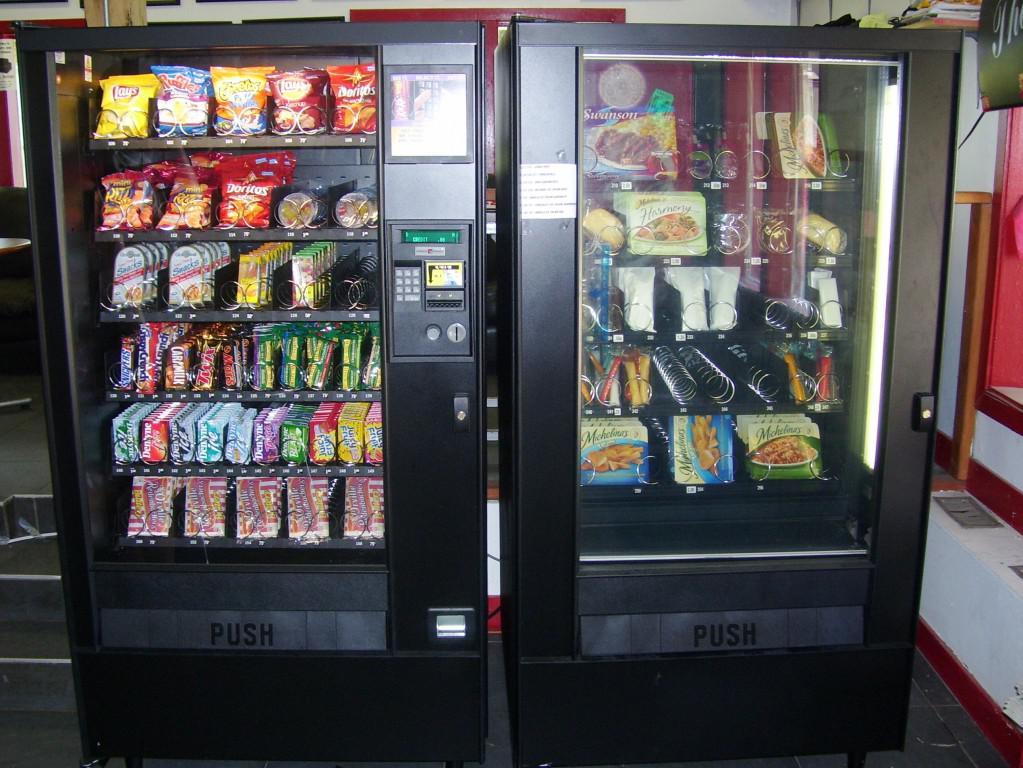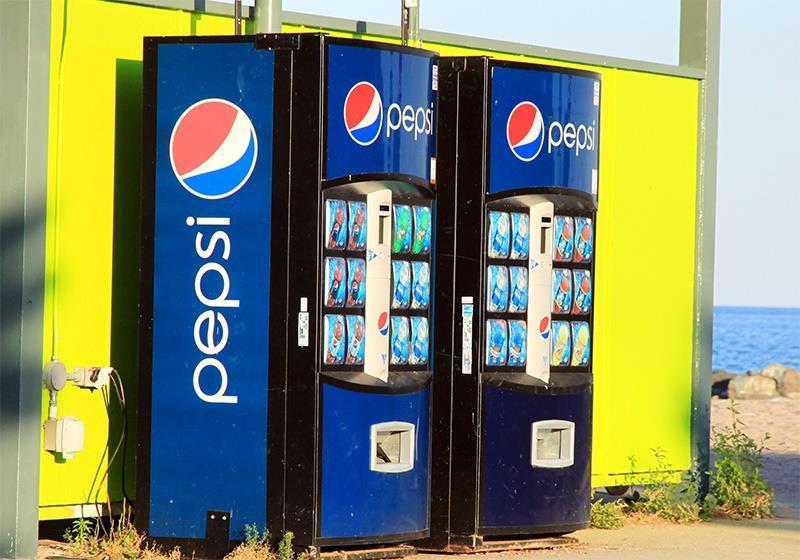The first image is the image on the left, the second image is the image on the right. Assess this claim about the two images: "Left image shows a vending machine that does not dispense beverages.". Correct or not? Answer yes or no. Yes. The first image is the image on the left, the second image is the image on the right. For the images displayed, is the sentence "there are red vending machines" factually correct? Answer yes or no. No. 